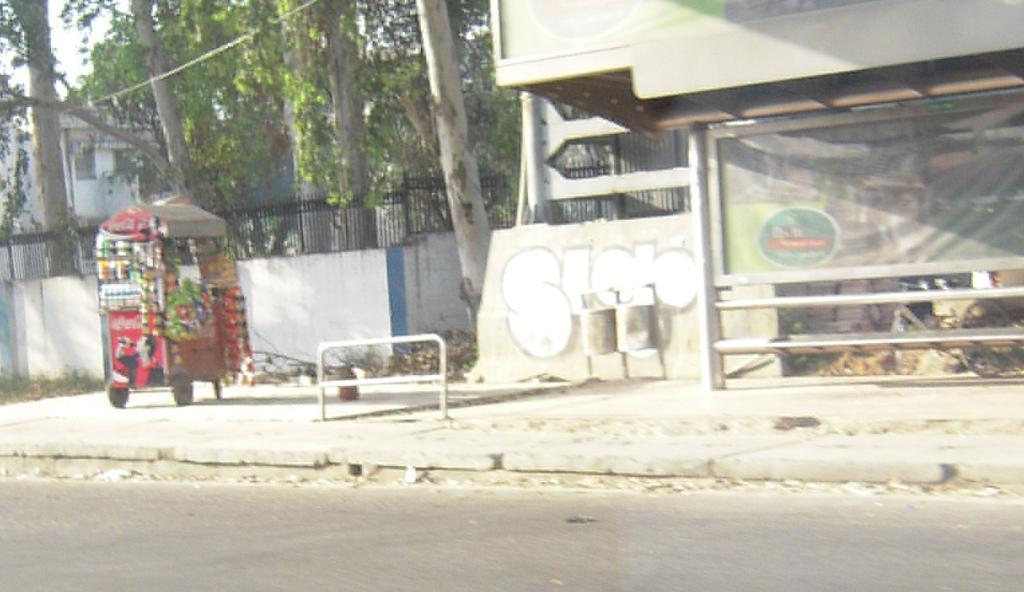In one or two sentences, can you explain what this image depicts? In this image we can see a stall with some objects, wall with iron fence, a shed and trees, building and sky in the background. 